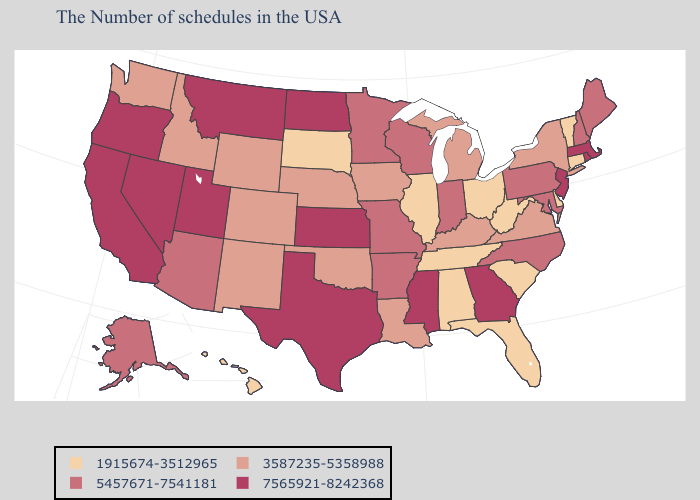Which states have the lowest value in the USA?
Keep it brief. Vermont, Connecticut, Delaware, South Carolina, West Virginia, Ohio, Florida, Alabama, Tennessee, Illinois, South Dakota, Hawaii. Among the states that border Virginia , which have the lowest value?
Short answer required. West Virginia, Tennessee. Does Vermont have the highest value in the USA?
Write a very short answer. No. Name the states that have a value in the range 5457671-7541181?
Short answer required. Maine, New Hampshire, Maryland, Pennsylvania, North Carolina, Indiana, Wisconsin, Missouri, Arkansas, Minnesota, Arizona, Alaska. Name the states that have a value in the range 1915674-3512965?
Keep it brief. Vermont, Connecticut, Delaware, South Carolina, West Virginia, Ohio, Florida, Alabama, Tennessee, Illinois, South Dakota, Hawaii. Name the states that have a value in the range 1915674-3512965?
Short answer required. Vermont, Connecticut, Delaware, South Carolina, West Virginia, Ohio, Florida, Alabama, Tennessee, Illinois, South Dakota, Hawaii. What is the value of Georgia?
Quick response, please. 7565921-8242368. What is the value of Ohio?
Answer briefly. 1915674-3512965. Among the states that border Idaho , which have the highest value?
Quick response, please. Utah, Montana, Nevada, Oregon. Name the states that have a value in the range 1915674-3512965?
Write a very short answer. Vermont, Connecticut, Delaware, South Carolina, West Virginia, Ohio, Florida, Alabama, Tennessee, Illinois, South Dakota, Hawaii. What is the value of Georgia?
Quick response, please. 7565921-8242368. What is the value of North Carolina?
Be succinct. 5457671-7541181. What is the highest value in the South ?
Concise answer only. 7565921-8242368. Does Alabama have the lowest value in the USA?
Quick response, please. Yes. Name the states that have a value in the range 7565921-8242368?
Give a very brief answer. Massachusetts, Rhode Island, New Jersey, Georgia, Mississippi, Kansas, Texas, North Dakota, Utah, Montana, Nevada, California, Oregon. 